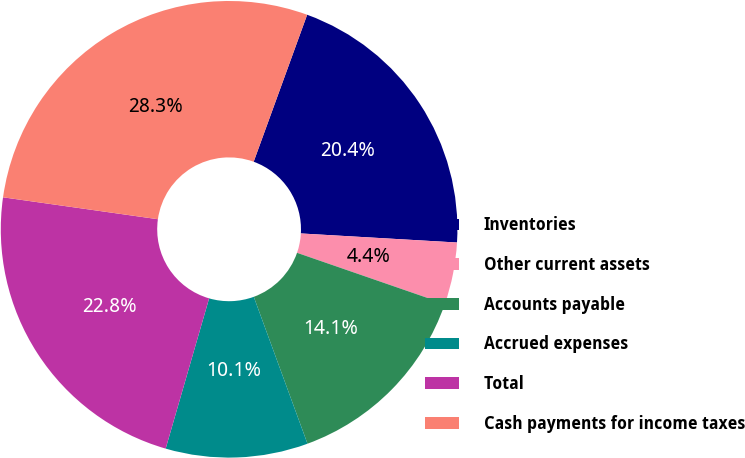Convert chart. <chart><loc_0><loc_0><loc_500><loc_500><pie_chart><fcel>Inventories<fcel>Other current assets<fcel>Accounts payable<fcel>Accrued expenses<fcel>Total<fcel>Cash payments for income taxes<nl><fcel>20.37%<fcel>4.38%<fcel>14.12%<fcel>10.06%<fcel>22.76%<fcel>28.32%<nl></chart> 